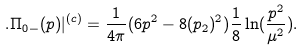Convert formula to latex. <formula><loc_0><loc_0><loc_500><loc_500>. \Pi _ { 0 - } ( p ) | ^ { ( c ) } = \frac { 1 } { 4 \pi } ( 6 p ^ { 2 } - 8 ( p _ { 2 } ) ^ { 2 } ) \frac { 1 } { 8 } \ln ( \frac { p ^ { 2 } } { \mu ^ { 2 } } ) .</formula> 